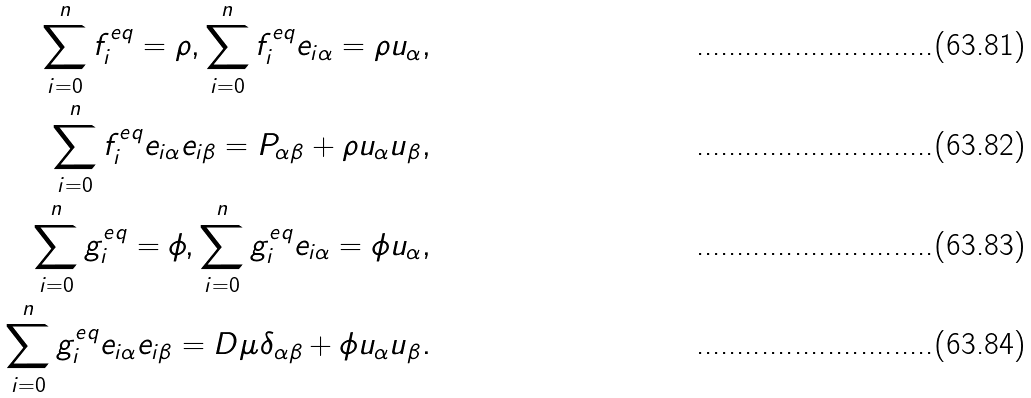Convert formula to latex. <formula><loc_0><loc_0><loc_500><loc_500>\sum _ { i = 0 } ^ { n } f ^ { e q } _ { i } = \rho , \sum _ { i = 0 } ^ { n } f ^ { e q } _ { i } e _ { i \alpha } = \rho u _ { \alpha } , \\ \sum _ { i = 0 } ^ { n } f ^ { e q } _ { i } e _ { i \alpha } e _ { i \beta } = P _ { \alpha \beta } + \rho u _ { \alpha } u { _ { \beta } } , \\ \sum _ { i = 0 } ^ { n } g ^ { e q } _ { i } = \phi , \sum _ { i = 0 } ^ { n } g ^ { e q } _ { i } e _ { i \alpha } = \phi u _ { \alpha } , \\ \sum _ { i = 0 } ^ { n } g ^ { e q } _ { i } e _ { i \alpha } e _ { i \beta } = D \mu \delta _ { \alpha \beta } + \phi u _ { \alpha } u { _ { \beta } } .</formula> 